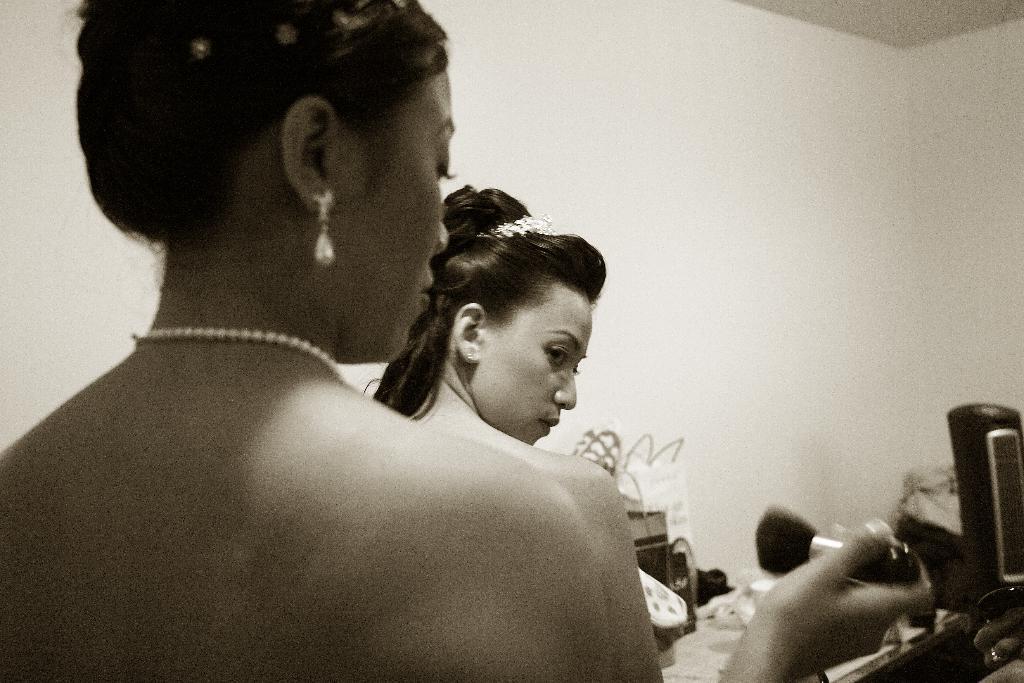Could you give a brief overview of what you see in this image? This is a black and white picture, there are two persons, there is a person holding a makeup brush, there are bags and some other objects, and in the background there is a wall. 